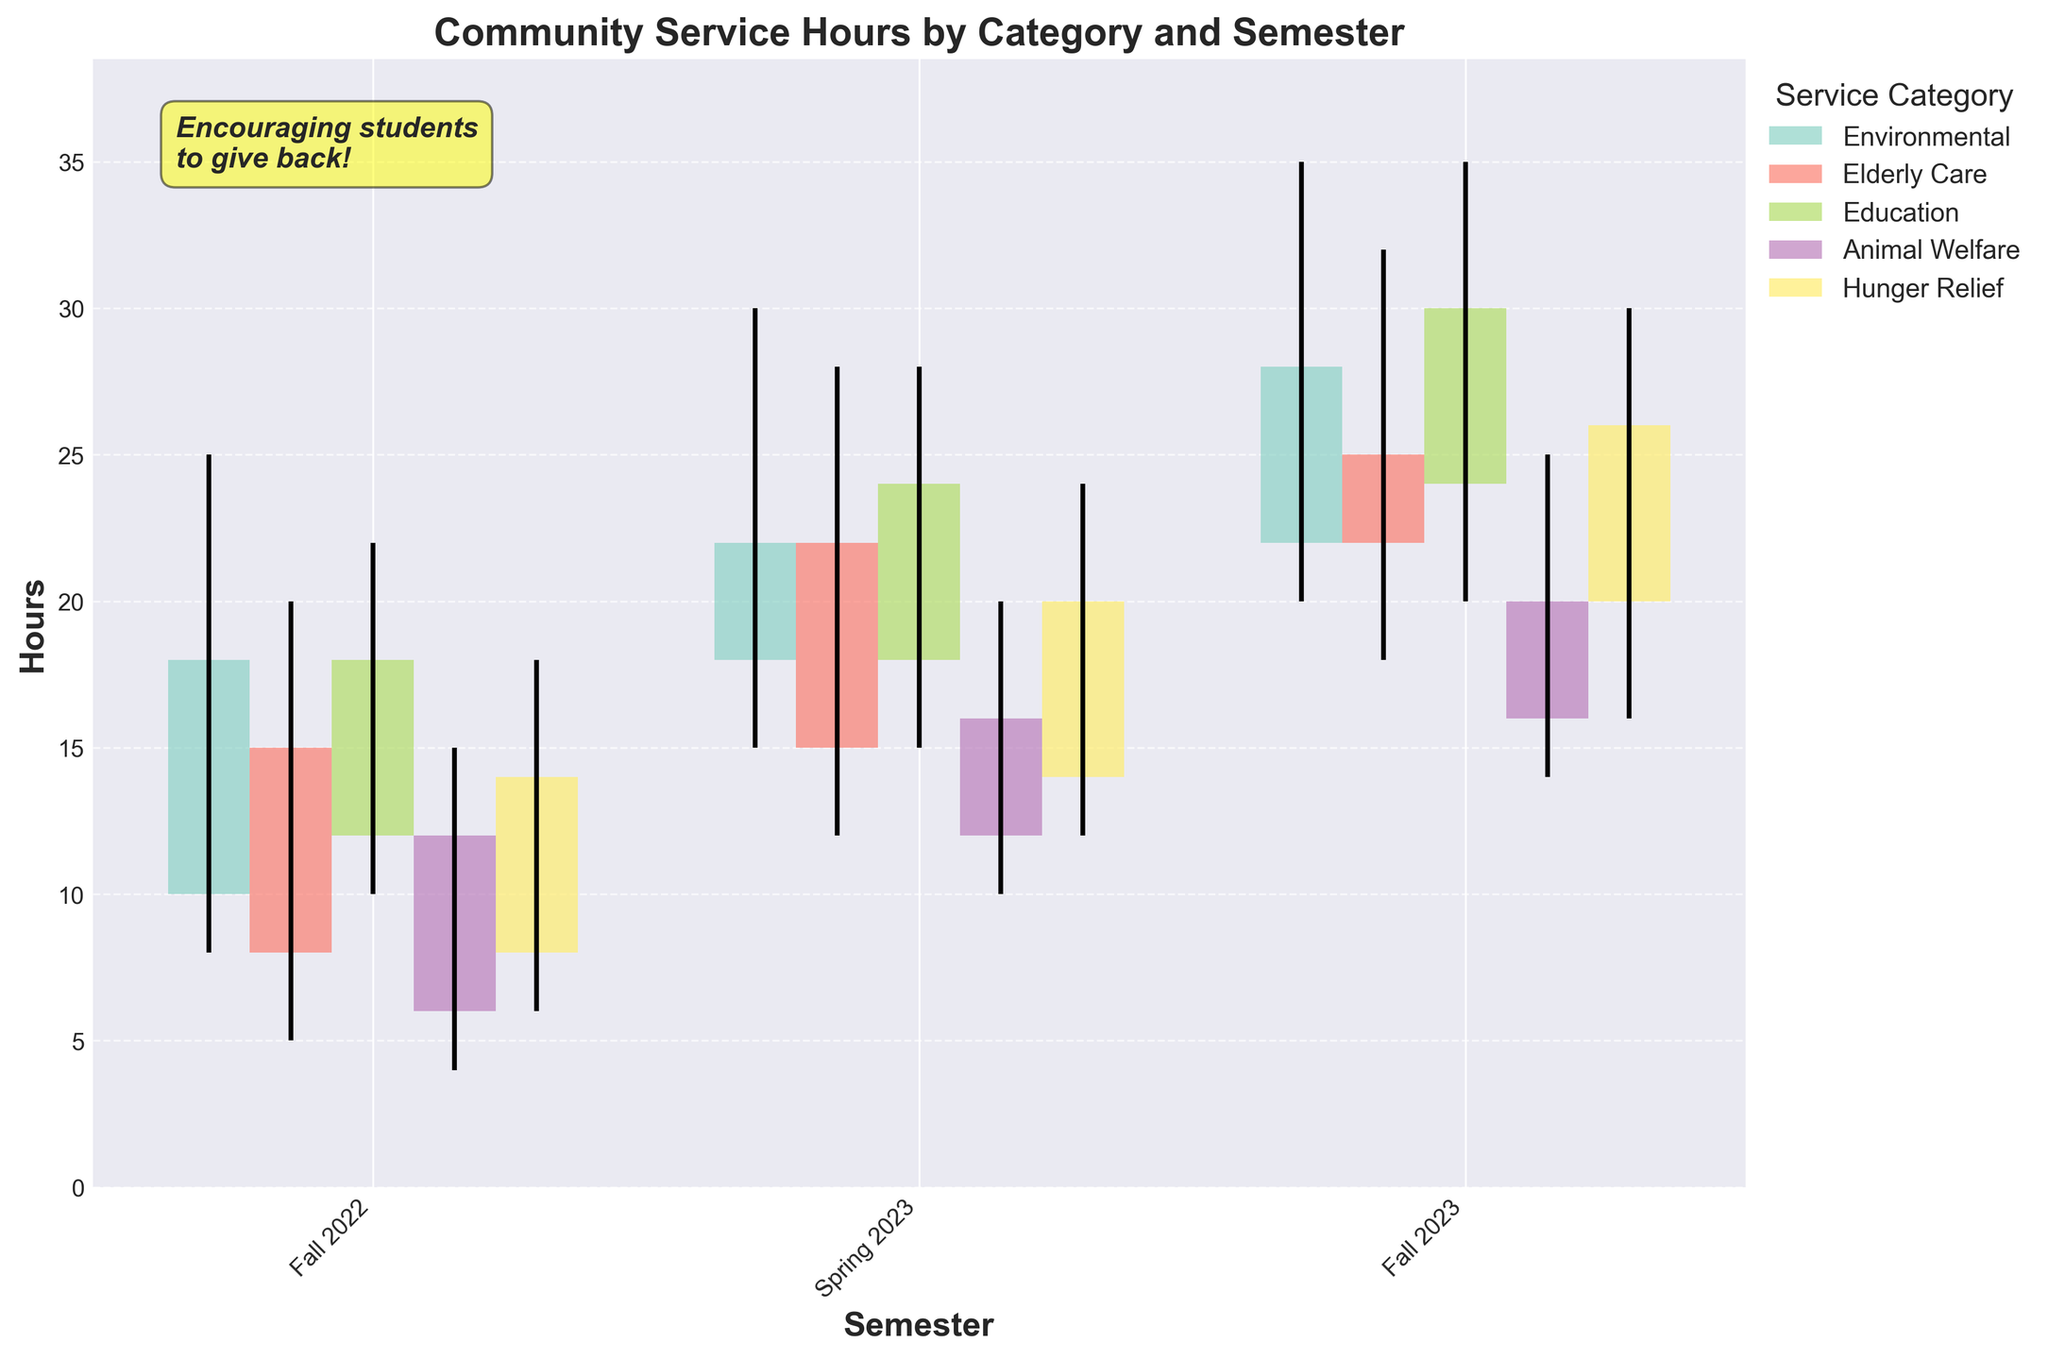what is the title of the figure? The title is usually located at the top of the chart, and it provides a brief description of what the chart is about. Here, it is "Community Service Hours by Category and Semester".
Answer: Community Service Hours by Category and Semester how many categories of community service are represented in the chart? The legend on the right side of the chart lists all the different categories of community service. From the legend, we can see there are five categories.
Answer: 5 what is the highest number of hours spent on a single category in any semester? The highest value can be identified by looking for the tallest bar in the chart or the maximum value in the vertical black lines. In Spring 2023 for the Education category, the highest number of hours recorded is 35.
Answer: 35 which category saw the most significant increase in hours from Fall 2022 to Fall 2023? By comparing the bars for each category, we can see how much they increased from Fall 2022 to Fall 2023. The Hunger Relief category increased from 14 hours to 26 hours, an increase of 12 hours, which is the largest among all categories.
Answer: Hunger Relief what is the range of hours spent on Animal Welfare in Fall 2023? The range can be calculated by finding the difference between the highest and lowest values indicated by the vertical black lines for the specific category and semester. In Fall 2023 for Animal Welfare, the range is from 14 to 25 hours, so 25 - 14 = 11.
Answer: 11 which semester has the highest average number of hours across all categories? To find the average for each semester, first, calculate the sum of the "Close" values for each semester and divide by the number of categories. Compute this for each semester and compare. Spring 2023 has the highest averages across all categories.
Answer: Spring 2023 how does the fluctuation in hours for Environmental activities in Spring 2023 compare to Fall 2022? The fluctuation is shown by the length of the vertical black lines (high minus low). In Fall 2022, the range for Environmental is 25 - 8 = 17 hours. In Spring 2023, it is 30 - 15 = 15 hours. There is less fluctuation in Spring 2023 compared to Fall 2022.
Answer: Less fluctuation what is the overall trend in community service hours for the Education category from Fall 2022 to Fall 2023? By observing the close values, which represent the hours at the end of each semester, there's a clear increasing trend: 18 hours in Fall 2022, 24 hours in Spring 2023, and 30 hours in Fall 2023.
Answer: Increasing trend which category showed the least fluctuation in hours in Fall 2023? The least fluctuation is indicated by the shortest vertical black line for Fall 2023. Elderly Care has a fluctuation range between 32 and 18, making it the smallest difference of 14.
Answer: Elderly Care 